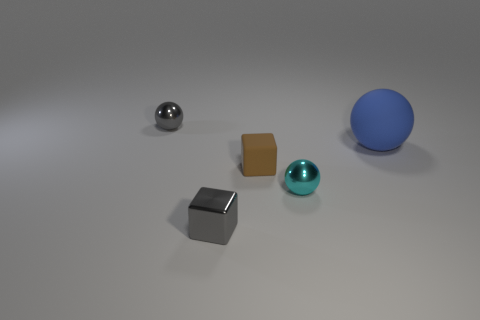Add 2 blue matte spheres. How many objects exist? 7 Subtract all balls. How many objects are left? 2 Subtract 0 blue cylinders. How many objects are left? 5 Subtract all big green objects. Subtract all shiny spheres. How many objects are left? 3 Add 4 gray spheres. How many gray spheres are left? 5 Add 4 tiny blue metallic cylinders. How many tiny blue metallic cylinders exist? 4 